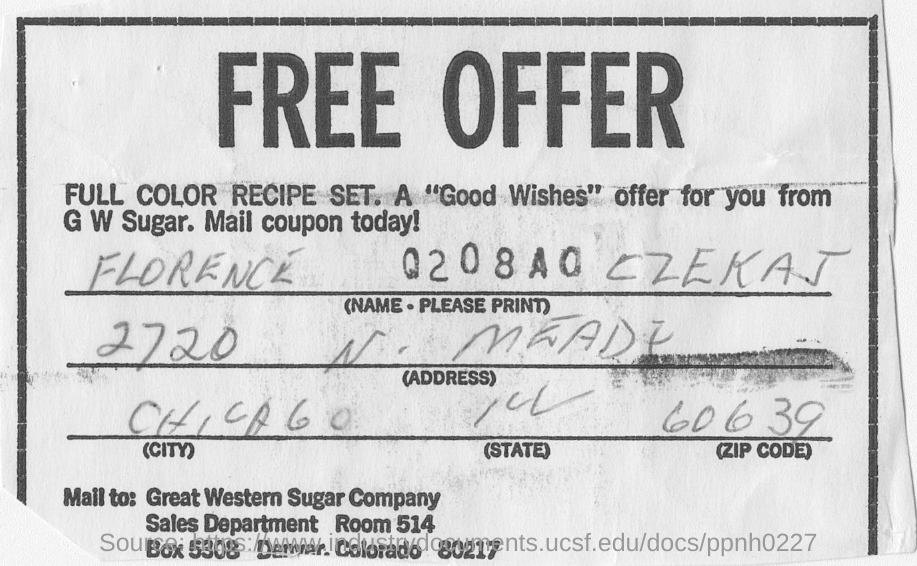Mention a couple of crucial points in this snapshot. FLORENCE CZEKAJ is located in the city of CHICAGO. 